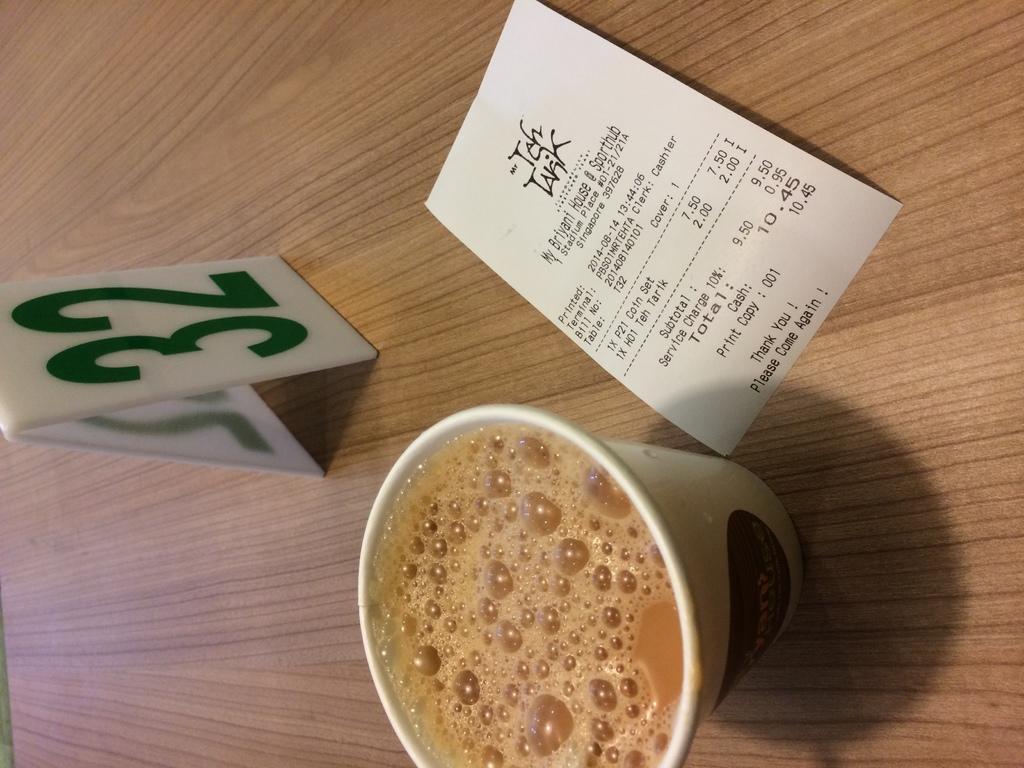Please provide a concise description of this image. In this image, we can see the table, there is a glass with tea in it on the table, we can see the bill and there is a number board on the table. 